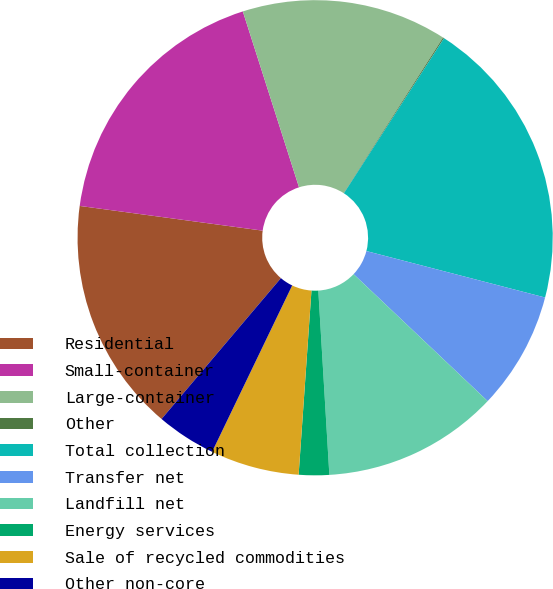Convert chart. <chart><loc_0><loc_0><loc_500><loc_500><pie_chart><fcel>Residential<fcel>Small-container<fcel>Large-container<fcel>Other<fcel>Total collection<fcel>Transfer net<fcel>Landfill net<fcel>Energy services<fcel>Sale of recycled commodities<fcel>Other non-core<nl><fcel>15.95%<fcel>17.94%<fcel>13.97%<fcel>0.08%<fcel>19.92%<fcel>8.02%<fcel>11.98%<fcel>2.06%<fcel>6.03%<fcel>4.05%<nl></chart> 